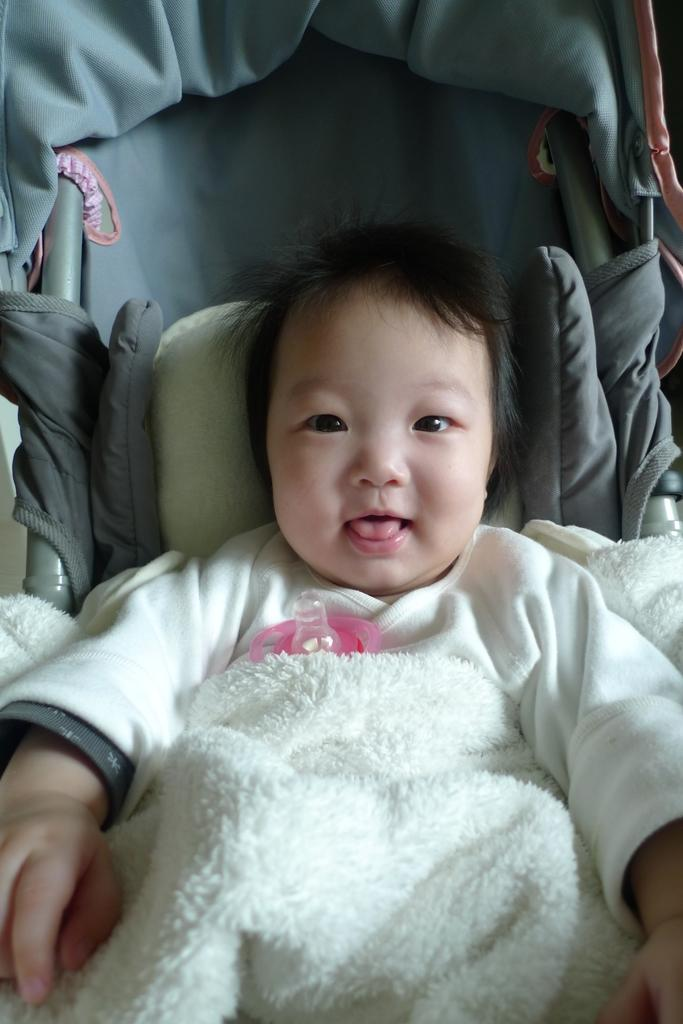What is the main subject of the image? The main subject of the image is a baby. What is the baby wearing? The baby is wearing clothes. Where is the baby located in the image? The baby is sitting in a baby cart. Can you describe any other objects or materials in the image? There is a white cloth visible in the image. What type of doll is sitting next to the baby in the image? There is no doll present in the image; it only features a baby sitting in a baby cart and a white cloth. 